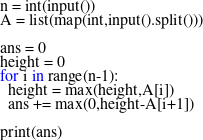Convert code to text. <code><loc_0><loc_0><loc_500><loc_500><_Python_>n = int(input())
A = list(map(int,input().split()))

ans = 0
height = 0
for i in range(n-1):
  height = max(height,A[i])
  ans += max(0,height-A[i+1])
  
print(ans)  </code> 